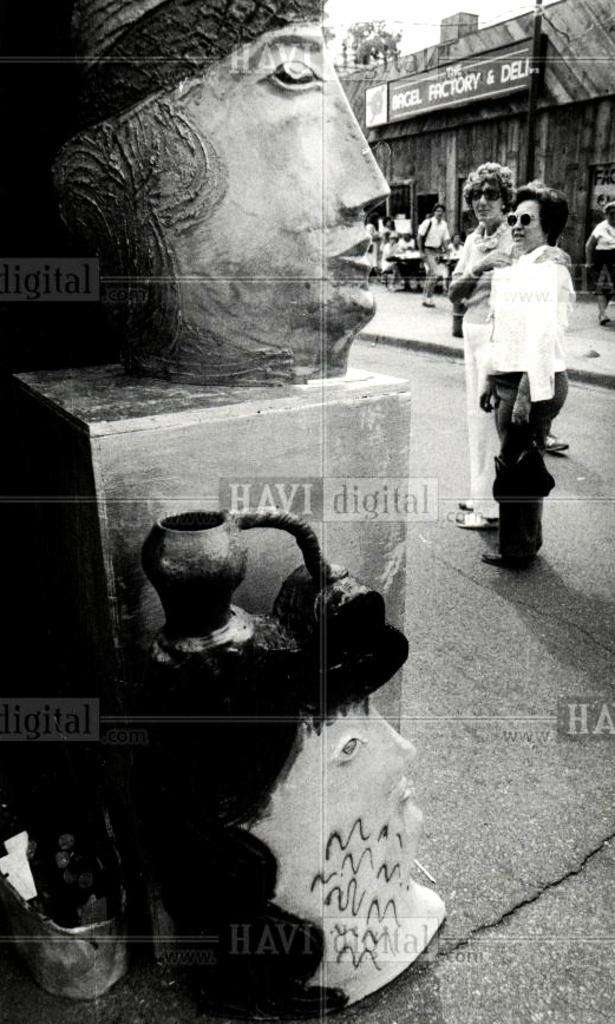What is the color scheme of the image? The image is black and white. What type of objects can be seen in the image? There are sculptures in the image. Are there any people present in the image? Yes, there are people in the image. What can be seen in the background of the image? There is a building, trees, and a hoarding in the background of the image. Can you see the veil on the sculpture in the image? There is no veil present on any of the sculptures in the image. What type of coach is parked near the building in the image? There is no coach visible in the image; only a building, trees, and a hoarding can be seen in the background. 